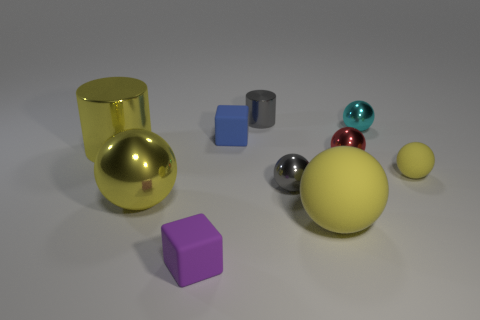There is a object that is the same color as the small metallic cylinder; what shape is it?
Provide a short and direct response. Sphere. Are there fewer matte balls to the right of the small yellow matte ball than big spheres that are left of the big yellow metallic cylinder?
Provide a succinct answer. No. What is the material of the object that is behind the tiny blue rubber thing and in front of the gray shiny cylinder?
Offer a very short reply. Metal. There is a big object that is on the right side of the small thing that is to the left of the blue matte cube; what shape is it?
Offer a terse response. Sphere. Is the large metal sphere the same color as the large rubber ball?
Provide a succinct answer. Yes. What number of yellow things are either small matte balls or big things?
Your answer should be compact. 4. There is a purple matte object; are there any things right of it?
Keep it short and to the point. Yes. What size is the red ball?
Offer a terse response. Small. There is a gray shiny thing that is the same shape as the big rubber thing; what size is it?
Keep it short and to the point. Small. How many cyan metallic objects are left of the cube that is behind the purple thing?
Offer a very short reply. 0. 